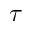<formula> <loc_0><loc_0><loc_500><loc_500>\tau</formula> 